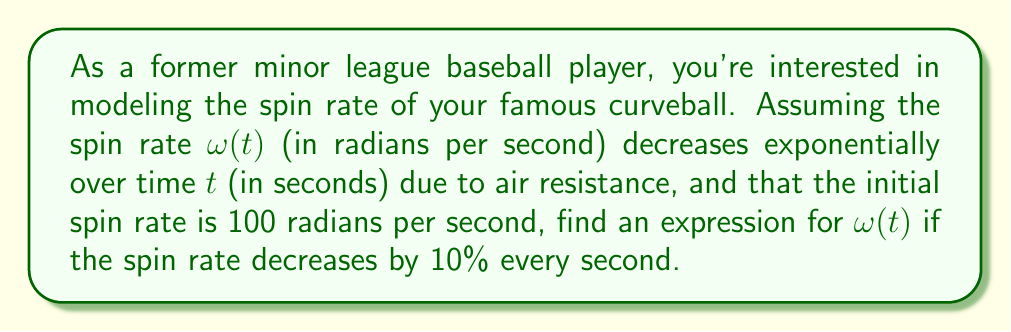Give your solution to this math problem. Let's approach this problem step-by-step using differential equations:

1) The rate of change of the spin rate is proportional to the current spin rate. This can be expressed as:

   $$\frac{d\omega}{dt} = -k\omega$$

   where $k$ is a positive constant representing the rate of decay.

2) We know that after 1 second, the spin rate is 90% of its initial value. Let's use this to find $k$:

   $$\omega(1) = 0.9\omega(0)$$

3) The general solution to the differential equation is:

   $$\omega(t) = \omega(0)e^{-kt}$$

4) Substituting $t=1$ and $\omega(1) = 0.9\omega(0)$:

   $$0.9\omega(0) = \omega(0)e^{-k}$$

5) Simplifying:

   $$0.9 = e^{-k}$$

6) Taking the natural log of both sides:

   $$\ln(0.9) = -k$$

7) Solving for $k$:

   $$k = -\ln(0.9) \approx 0.1054$$

8) Now that we have $k$, we can write the full solution:

   $$\omega(t) = 100e^{-0.1054t}$$

   where 100 is the initial spin rate in radians per second.
Answer: $$\omega(t) = 100e^{-0.1054t}$$ radians per second 